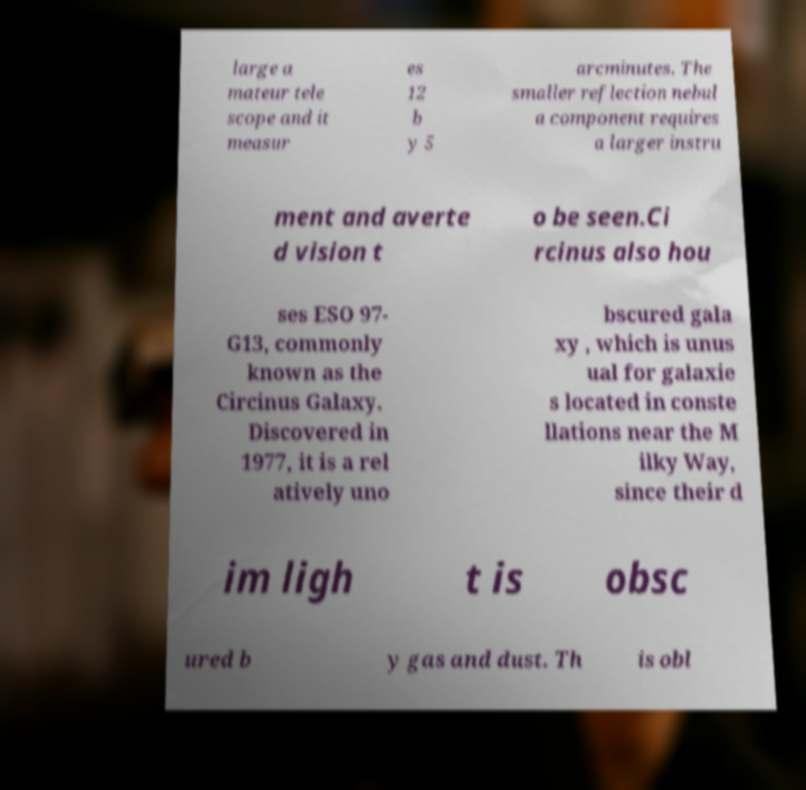What messages or text are displayed in this image? I need them in a readable, typed format. large a mateur tele scope and it measur es 12 b y 5 arcminutes. The smaller reflection nebul a component requires a larger instru ment and averte d vision t o be seen.Ci rcinus also hou ses ESO 97- G13, commonly known as the Circinus Galaxy. Discovered in 1977, it is a rel atively uno bscured gala xy , which is unus ual for galaxie s located in conste llations near the M ilky Way, since their d im ligh t is obsc ured b y gas and dust. Th is obl 